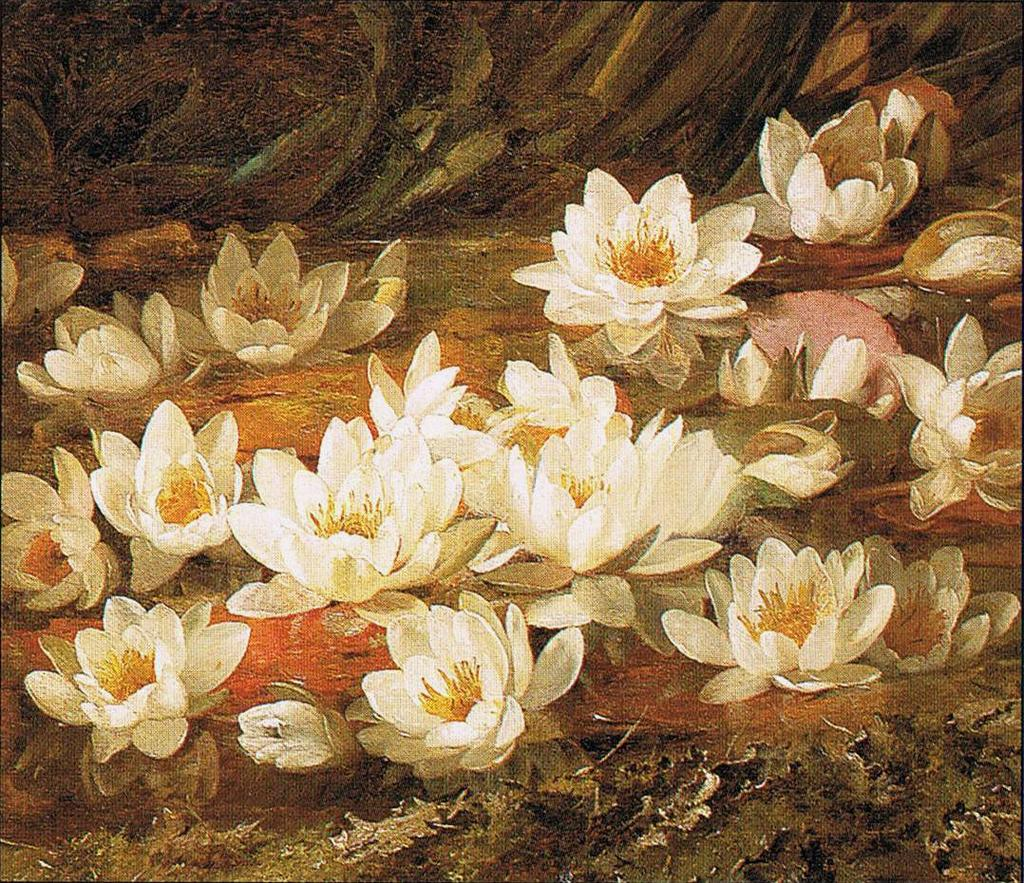What type of plants can be seen in the image? There are flowers in the image. What else is visible in the image besides the flowers? There is water visible in the image. Can you tell me how many knees are visible in the image? There are no knees visible in the image; it features flowers and water. What type of vegetable can be seen growing in the image? There are no vegetables present in the image; it features flowers and water. 